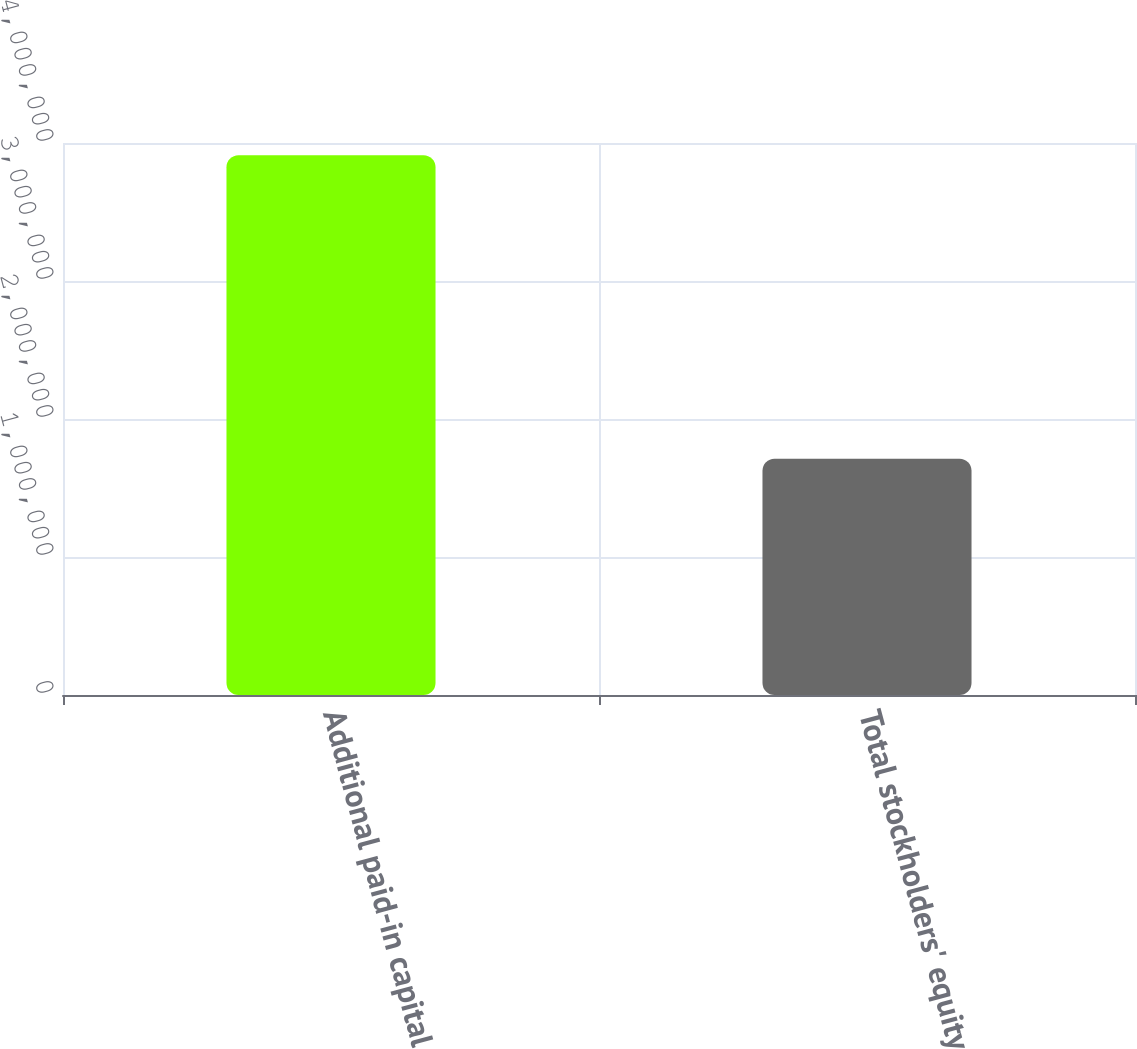Convert chart to OTSL. <chart><loc_0><loc_0><loc_500><loc_500><bar_chart><fcel>Additional paid-in capital<fcel>Total stockholders' equity<nl><fcel>3.91088e+06<fcel>1.71155e+06<nl></chart> 